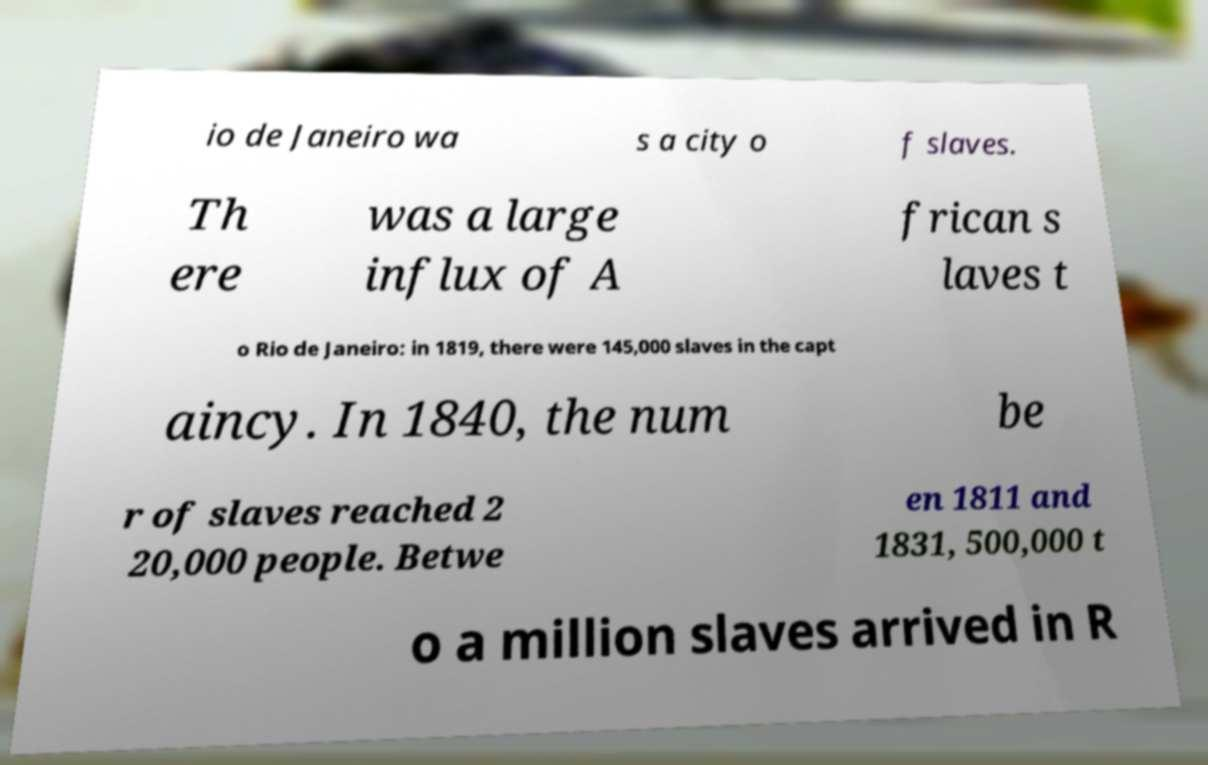Could you extract and type out the text from this image? io de Janeiro wa s a city o f slaves. Th ere was a large influx of A frican s laves t o Rio de Janeiro: in 1819, there were 145,000 slaves in the capt aincy. In 1840, the num be r of slaves reached 2 20,000 people. Betwe en 1811 and 1831, 500,000 t o a million slaves arrived in R 